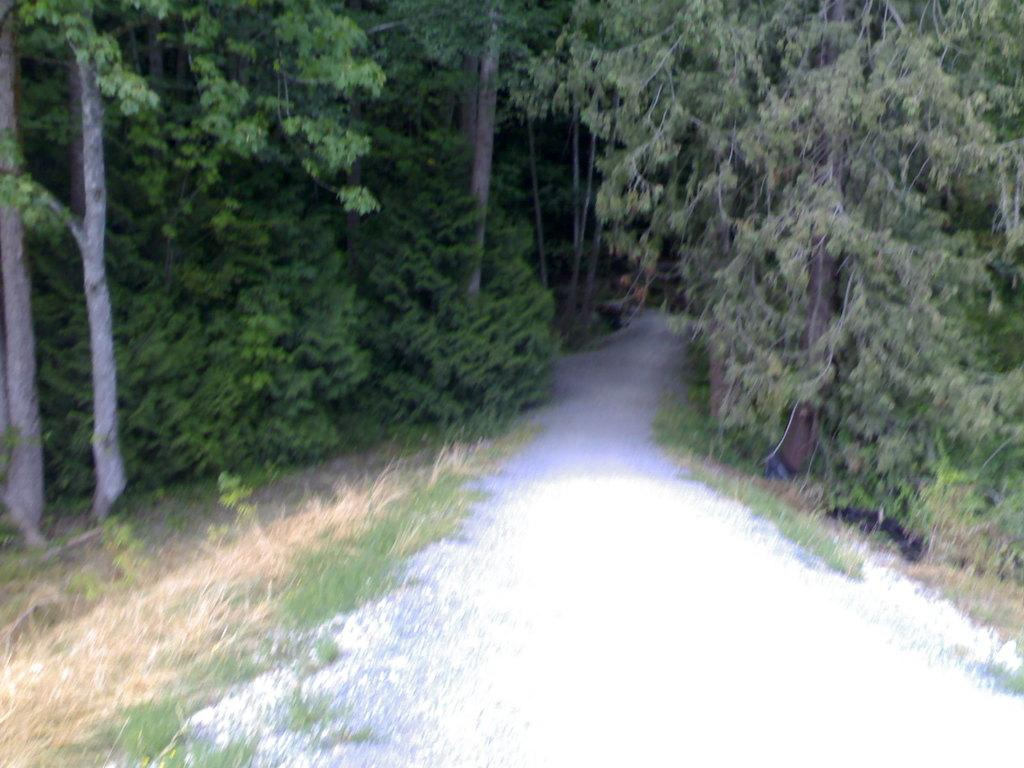What can be seen running through the center of the image? There is a path in the image. What type of vegetation is present on the right side of the path? Trees are present on the right side of the path. What type of vegetation is present on the left side of the path? Trees are present on the left side of the path. Can you see any bones scattered along the path in the image? There are no bones present in the image; it features a path with trees on either side. 